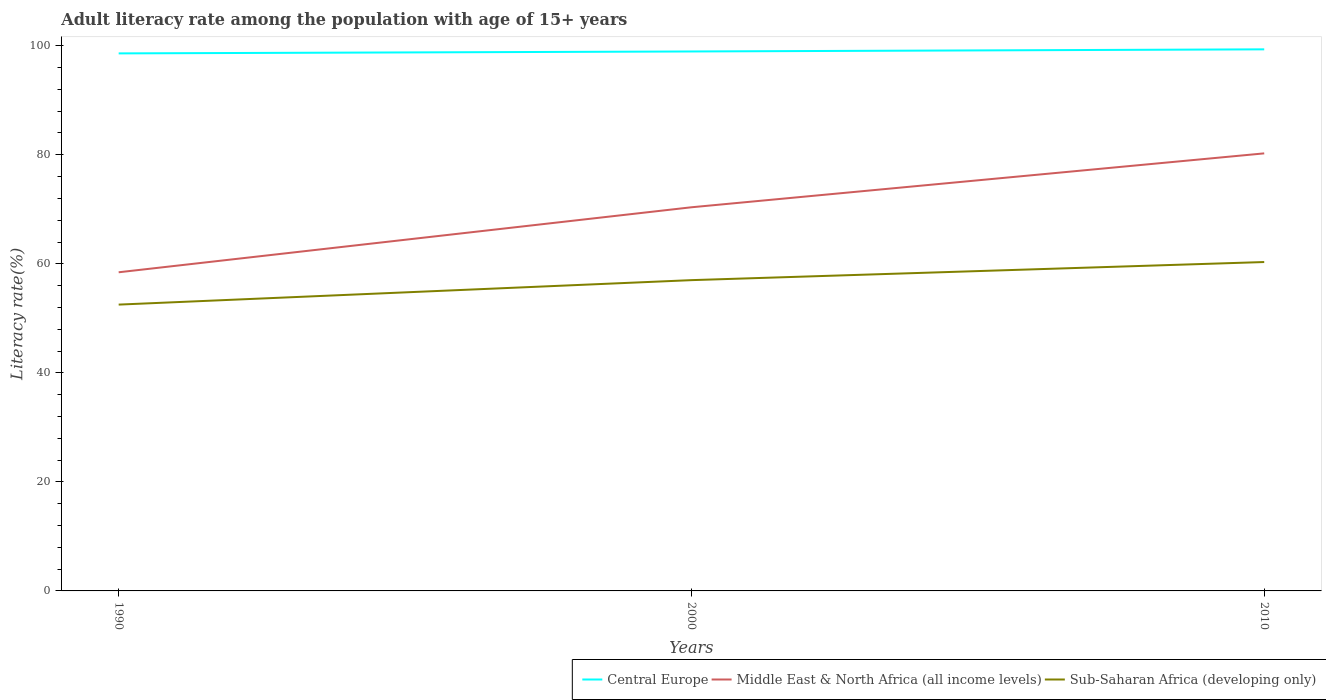Does the line corresponding to Central Europe intersect with the line corresponding to Sub-Saharan Africa (developing only)?
Offer a very short reply. No. Across all years, what is the maximum adult literacy rate in Sub-Saharan Africa (developing only)?
Ensure brevity in your answer.  52.52. What is the total adult literacy rate in Sub-Saharan Africa (developing only) in the graph?
Give a very brief answer. -7.81. What is the difference between the highest and the second highest adult literacy rate in Central Europe?
Give a very brief answer. 0.74. How many lines are there?
Your answer should be very brief. 3. What is the difference between two consecutive major ticks on the Y-axis?
Offer a very short reply. 20. Does the graph contain grids?
Keep it short and to the point. No. How many legend labels are there?
Your response must be concise. 3. How are the legend labels stacked?
Your response must be concise. Horizontal. What is the title of the graph?
Keep it short and to the point. Adult literacy rate among the population with age of 15+ years. What is the label or title of the Y-axis?
Provide a succinct answer. Literacy rate(%). What is the Literacy rate(%) in Central Europe in 1990?
Offer a very short reply. 98.6. What is the Literacy rate(%) in Middle East & North Africa (all income levels) in 1990?
Your answer should be compact. 58.45. What is the Literacy rate(%) of Sub-Saharan Africa (developing only) in 1990?
Make the answer very short. 52.52. What is the Literacy rate(%) of Central Europe in 2000?
Offer a terse response. 98.95. What is the Literacy rate(%) of Middle East & North Africa (all income levels) in 2000?
Ensure brevity in your answer.  70.37. What is the Literacy rate(%) in Sub-Saharan Africa (developing only) in 2000?
Give a very brief answer. 57.01. What is the Literacy rate(%) of Central Europe in 2010?
Ensure brevity in your answer.  99.34. What is the Literacy rate(%) in Middle East & North Africa (all income levels) in 2010?
Offer a terse response. 80.26. What is the Literacy rate(%) in Sub-Saharan Africa (developing only) in 2010?
Your response must be concise. 60.33. Across all years, what is the maximum Literacy rate(%) in Central Europe?
Make the answer very short. 99.34. Across all years, what is the maximum Literacy rate(%) of Middle East & North Africa (all income levels)?
Make the answer very short. 80.26. Across all years, what is the maximum Literacy rate(%) of Sub-Saharan Africa (developing only)?
Your answer should be compact. 60.33. Across all years, what is the minimum Literacy rate(%) in Central Europe?
Offer a terse response. 98.6. Across all years, what is the minimum Literacy rate(%) of Middle East & North Africa (all income levels)?
Your answer should be very brief. 58.45. Across all years, what is the minimum Literacy rate(%) of Sub-Saharan Africa (developing only)?
Ensure brevity in your answer.  52.52. What is the total Literacy rate(%) of Central Europe in the graph?
Your answer should be very brief. 296.89. What is the total Literacy rate(%) of Middle East & North Africa (all income levels) in the graph?
Provide a short and direct response. 209.08. What is the total Literacy rate(%) in Sub-Saharan Africa (developing only) in the graph?
Ensure brevity in your answer.  169.85. What is the difference between the Literacy rate(%) in Central Europe in 1990 and that in 2000?
Make the answer very short. -0.35. What is the difference between the Literacy rate(%) in Middle East & North Africa (all income levels) in 1990 and that in 2000?
Offer a very short reply. -11.92. What is the difference between the Literacy rate(%) of Sub-Saharan Africa (developing only) in 1990 and that in 2000?
Your response must be concise. -4.49. What is the difference between the Literacy rate(%) in Central Europe in 1990 and that in 2010?
Your answer should be compact. -0.74. What is the difference between the Literacy rate(%) in Middle East & North Africa (all income levels) in 1990 and that in 2010?
Make the answer very short. -21.81. What is the difference between the Literacy rate(%) of Sub-Saharan Africa (developing only) in 1990 and that in 2010?
Your answer should be compact. -7.81. What is the difference between the Literacy rate(%) in Central Europe in 2000 and that in 2010?
Provide a short and direct response. -0.39. What is the difference between the Literacy rate(%) in Middle East & North Africa (all income levels) in 2000 and that in 2010?
Offer a very short reply. -9.89. What is the difference between the Literacy rate(%) of Sub-Saharan Africa (developing only) in 2000 and that in 2010?
Make the answer very short. -3.32. What is the difference between the Literacy rate(%) of Central Europe in 1990 and the Literacy rate(%) of Middle East & North Africa (all income levels) in 2000?
Give a very brief answer. 28.22. What is the difference between the Literacy rate(%) of Central Europe in 1990 and the Literacy rate(%) of Sub-Saharan Africa (developing only) in 2000?
Offer a very short reply. 41.59. What is the difference between the Literacy rate(%) of Middle East & North Africa (all income levels) in 1990 and the Literacy rate(%) of Sub-Saharan Africa (developing only) in 2000?
Give a very brief answer. 1.44. What is the difference between the Literacy rate(%) in Central Europe in 1990 and the Literacy rate(%) in Middle East & North Africa (all income levels) in 2010?
Offer a terse response. 18.34. What is the difference between the Literacy rate(%) in Central Europe in 1990 and the Literacy rate(%) in Sub-Saharan Africa (developing only) in 2010?
Offer a very short reply. 38.27. What is the difference between the Literacy rate(%) in Middle East & North Africa (all income levels) in 1990 and the Literacy rate(%) in Sub-Saharan Africa (developing only) in 2010?
Keep it short and to the point. -1.88. What is the difference between the Literacy rate(%) in Central Europe in 2000 and the Literacy rate(%) in Middle East & North Africa (all income levels) in 2010?
Provide a succinct answer. 18.69. What is the difference between the Literacy rate(%) of Central Europe in 2000 and the Literacy rate(%) of Sub-Saharan Africa (developing only) in 2010?
Offer a terse response. 38.62. What is the difference between the Literacy rate(%) in Middle East & North Africa (all income levels) in 2000 and the Literacy rate(%) in Sub-Saharan Africa (developing only) in 2010?
Provide a succinct answer. 10.05. What is the average Literacy rate(%) of Central Europe per year?
Provide a succinct answer. 98.96. What is the average Literacy rate(%) of Middle East & North Africa (all income levels) per year?
Give a very brief answer. 69.69. What is the average Literacy rate(%) in Sub-Saharan Africa (developing only) per year?
Make the answer very short. 56.62. In the year 1990, what is the difference between the Literacy rate(%) of Central Europe and Literacy rate(%) of Middle East & North Africa (all income levels)?
Provide a short and direct response. 40.15. In the year 1990, what is the difference between the Literacy rate(%) in Central Europe and Literacy rate(%) in Sub-Saharan Africa (developing only)?
Keep it short and to the point. 46.08. In the year 1990, what is the difference between the Literacy rate(%) of Middle East & North Africa (all income levels) and Literacy rate(%) of Sub-Saharan Africa (developing only)?
Provide a short and direct response. 5.93. In the year 2000, what is the difference between the Literacy rate(%) in Central Europe and Literacy rate(%) in Middle East & North Africa (all income levels)?
Your answer should be very brief. 28.58. In the year 2000, what is the difference between the Literacy rate(%) in Central Europe and Literacy rate(%) in Sub-Saharan Africa (developing only)?
Offer a terse response. 41.94. In the year 2000, what is the difference between the Literacy rate(%) in Middle East & North Africa (all income levels) and Literacy rate(%) in Sub-Saharan Africa (developing only)?
Your answer should be very brief. 13.37. In the year 2010, what is the difference between the Literacy rate(%) of Central Europe and Literacy rate(%) of Middle East & North Africa (all income levels)?
Your answer should be compact. 19.08. In the year 2010, what is the difference between the Literacy rate(%) in Central Europe and Literacy rate(%) in Sub-Saharan Africa (developing only)?
Your answer should be compact. 39.01. In the year 2010, what is the difference between the Literacy rate(%) of Middle East & North Africa (all income levels) and Literacy rate(%) of Sub-Saharan Africa (developing only)?
Provide a short and direct response. 19.93. What is the ratio of the Literacy rate(%) in Central Europe in 1990 to that in 2000?
Provide a short and direct response. 1. What is the ratio of the Literacy rate(%) in Middle East & North Africa (all income levels) in 1990 to that in 2000?
Keep it short and to the point. 0.83. What is the ratio of the Literacy rate(%) of Sub-Saharan Africa (developing only) in 1990 to that in 2000?
Offer a terse response. 0.92. What is the ratio of the Literacy rate(%) in Central Europe in 1990 to that in 2010?
Your answer should be very brief. 0.99. What is the ratio of the Literacy rate(%) in Middle East & North Africa (all income levels) in 1990 to that in 2010?
Provide a short and direct response. 0.73. What is the ratio of the Literacy rate(%) of Sub-Saharan Africa (developing only) in 1990 to that in 2010?
Keep it short and to the point. 0.87. What is the ratio of the Literacy rate(%) of Middle East & North Africa (all income levels) in 2000 to that in 2010?
Your answer should be very brief. 0.88. What is the ratio of the Literacy rate(%) of Sub-Saharan Africa (developing only) in 2000 to that in 2010?
Provide a succinct answer. 0.94. What is the difference between the highest and the second highest Literacy rate(%) of Central Europe?
Provide a short and direct response. 0.39. What is the difference between the highest and the second highest Literacy rate(%) of Middle East & North Africa (all income levels)?
Offer a terse response. 9.89. What is the difference between the highest and the second highest Literacy rate(%) of Sub-Saharan Africa (developing only)?
Make the answer very short. 3.32. What is the difference between the highest and the lowest Literacy rate(%) in Central Europe?
Your answer should be very brief. 0.74. What is the difference between the highest and the lowest Literacy rate(%) in Middle East & North Africa (all income levels)?
Provide a short and direct response. 21.81. What is the difference between the highest and the lowest Literacy rate(%) in Sub-Saharan Africa (developing only)?
Your response must be concise. 7.81. 